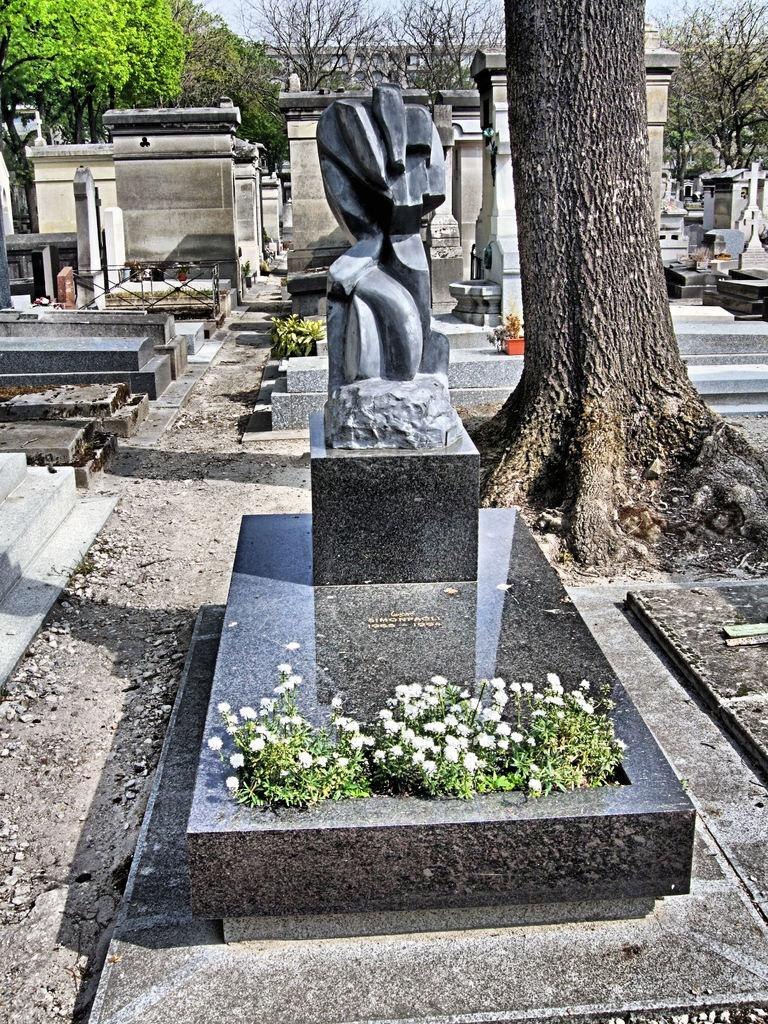What can be seen in the image that represents a final resting place? There are graves in the image. Are there any decorations or offerings present in the image? Yes, there are flowers in the image. What can be seen in the background of the image? There are trees in the background of the image. What type of clock is present on the graves in the image? There is no clock present on the graves in the image. How many cakes are placed on the graves in the image? There are no cakes present on the graves in the image. 